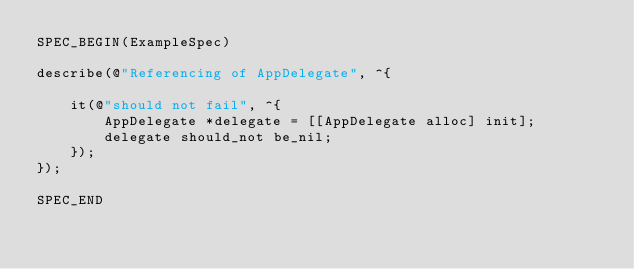<code> <loc_0><loc_0><loc_500><loc_500><_ObjectiveC_>SPEC_BEGIN(ExampleSpec)

describe(@"Referencing of AppDelegate", ^{

    it(@"should not fail", ^{
        AppDelegate *delegate = [[AppDelegate alloc] init];
        delegate should_not be_nil;
    });
});

SPEC_END

</code> 